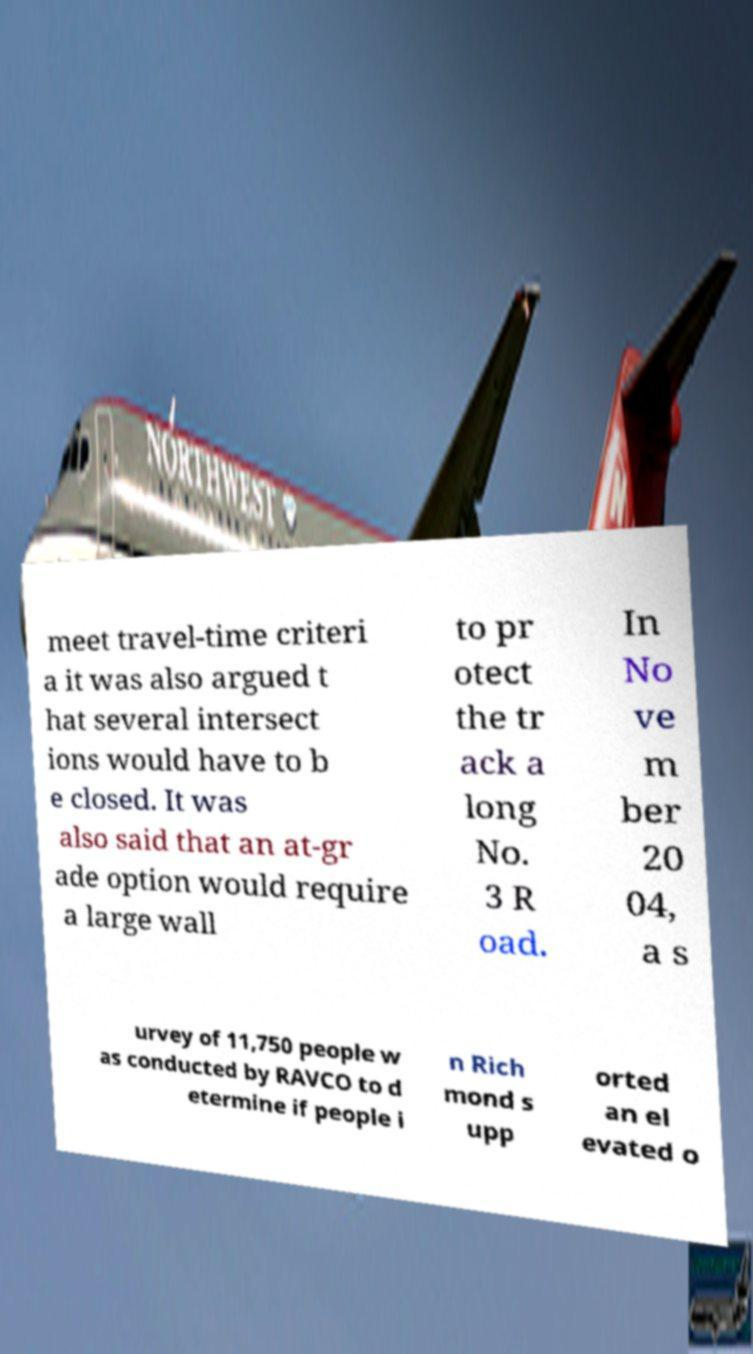Can you read and provide the text displayed in the image?This photo seems to have some interesting text. Can you extract and type it out for me? meet travel-time criteri a it was also argued t hat several intersect ions would have to b e closed. It was also said that an at-gr ade option would require a large wall to pr otect the tr ack a long No. 3 R oad. In No ve m ber 20 04, a s urvey of 11,750 people w as conducted by RAVCO to d etermine if people i n Rich mond s upp orted an el evated o 